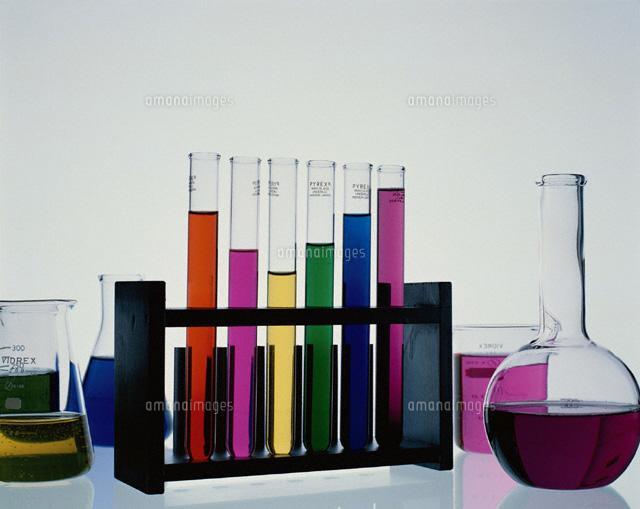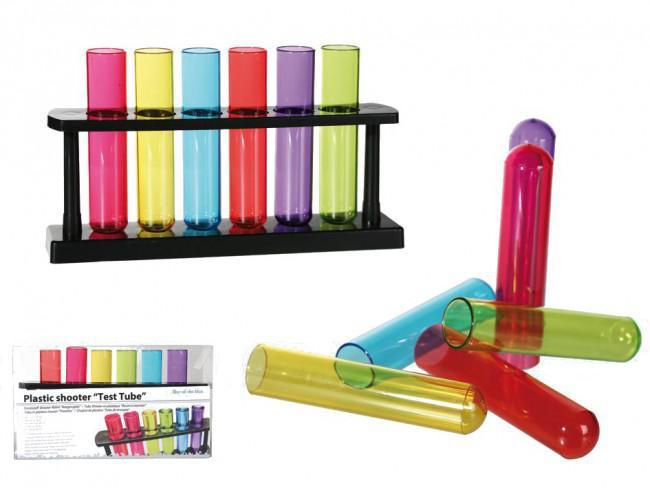The first image is the image on the left, the second image is the image on the right. Given the left and right images, does the statement "The containers in each of the images are all long and slender." hold true? Answer yes or no. No. The first image is the image on the left, the second image is the image on the right. Examine the images to the left and right. Is the description "The left image shows a beaker of purple liquid to the front and right of a stand containing test tubes, at least two with purple liquid in them." accurate? Answer yes or no. Yes. 